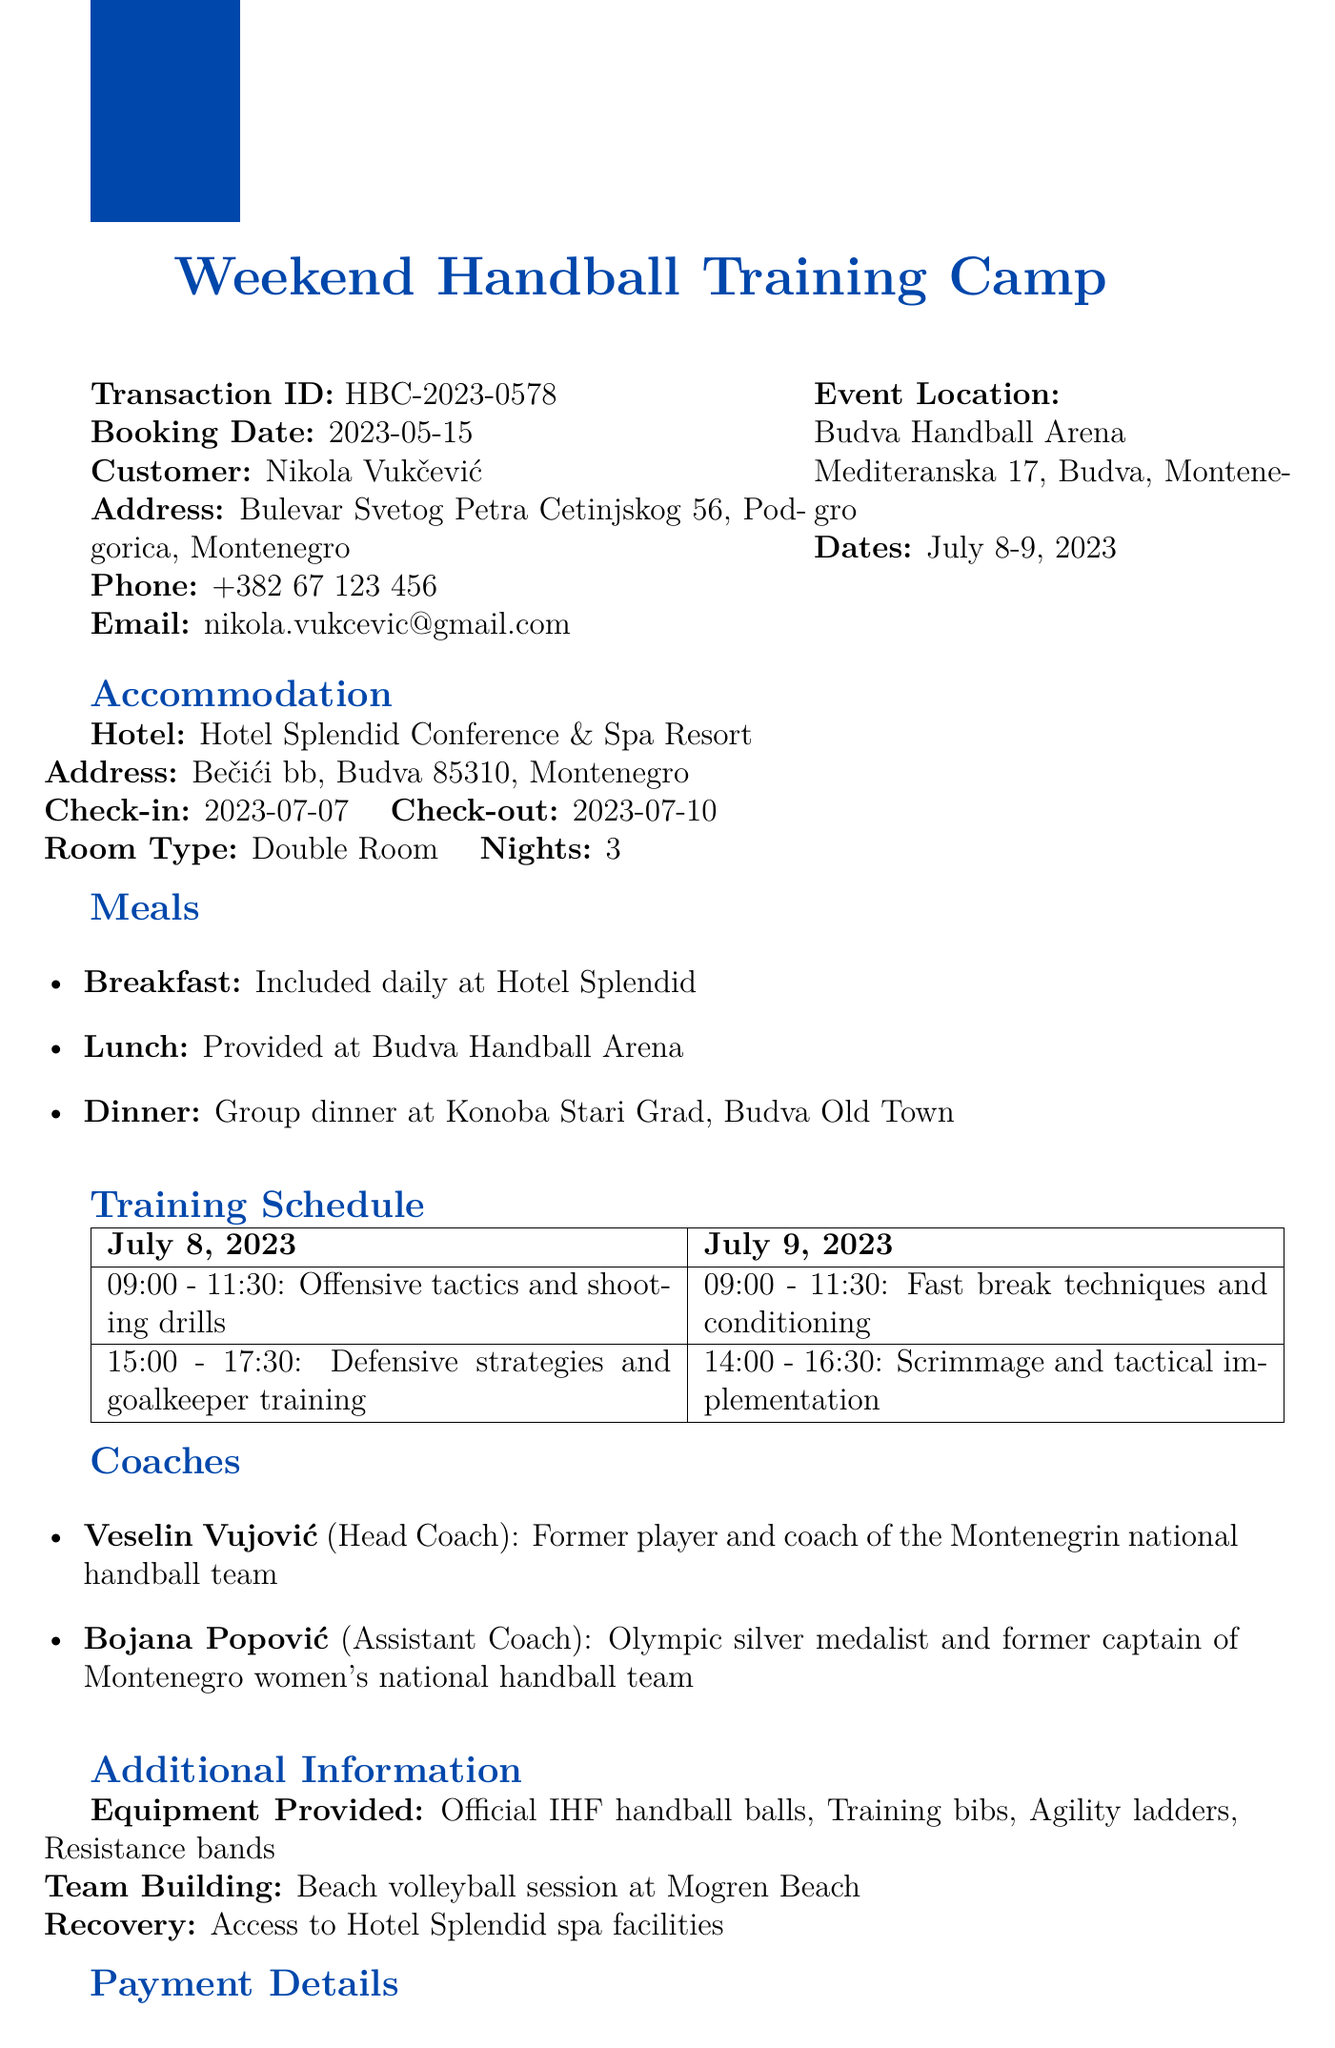What is the transaction ID? The transaction ID is a unique identifier for the transaction, listed in the document.
Answer: HBC-2023-0578 Who is the head coach? The head coach is mentioned in the coaches' section of the document, indicating their role.
Answer: Veselin Vujović What is the total amount paid? The total amount paid reflects the cost of the training camp as stated in the payment details.
Answer: 450 EUR What is the check-in date for the accommodation? The check-in date specifies when the accommodation can be accessed as per the accommodation section.
Answer: 2023-07-07 How many nights will the customer stay? The number of nights is specified under the accommodation details in the document.
Answer: 3 What type of meals are included? The included meals are detailed in the meals section, outlining what is provided during the stay.
Answer: Breakfast, Lunch, Dinner What cancellation policy is outlined? The cancellation policy details the terms under which refunds are granted, located in the document.
Answer: Full refund if cancelled 14 days before the event What activities are listed as additional activities? The additional activities provide insight into other features of the training camp aside from handball practice.
Answer: Beach volleyball session, access to spa facilities What is the email address of the contact person? The email address of the contact person is provided for any inquiries, found in the contact section.
Answer: marko.simic@budhccamp.me 